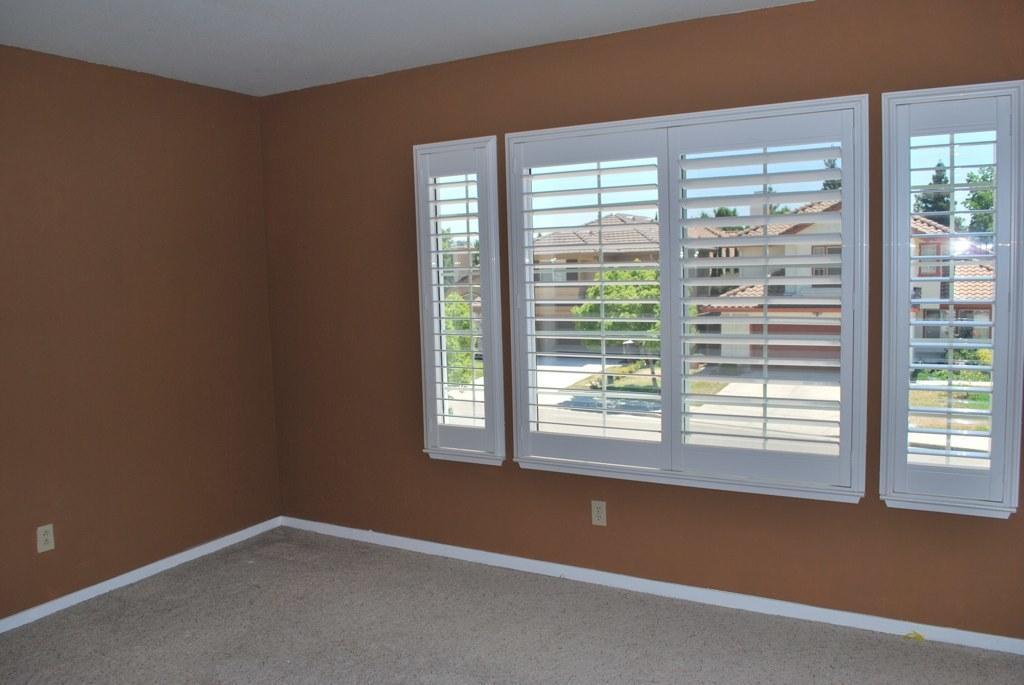In one or two sentences, can you explain what this image depicts? In this image we can see an inside view of a room, there are windows to the wall and white color objects looks like switches to the wall and through the windows we can see few buildings, trees and the sky. 